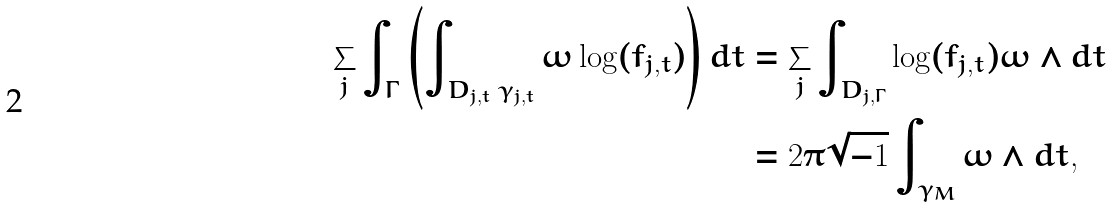<formula> <loc_0><loc_0><loc_500><loc_500>\sum _ { j } \int _ { \Gamma } \left ( \int _ { D _ { j , t } \ \gamma _ { j , t } } \omega \log ( f _ { j , t } ) \right ) d t & = \sum _ { j } \int _ { D _ { j , \Gamma } } \log ( f _ { j , t } ) \omega \wedge d t \\ & = 2 \pi \sqrt { - 1 } \int _ { \gamma _ { M } } \omega \wedge d t ,</formula> 